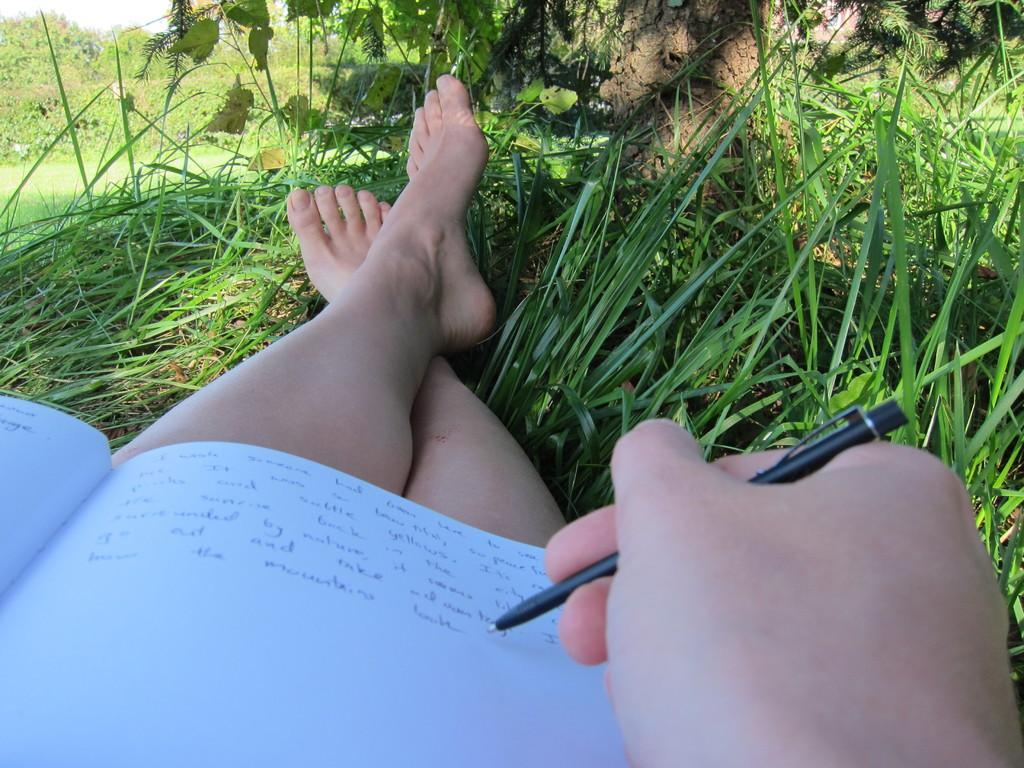Who is the main subject in the image? There is a woman in the image. What is the woman doing in the image? The woman is writing on a book. Where is the book placed in the image? The book is placed on her lap. What type of natural environment is visible in the image? There is grass, plants, and trees visible in the image. What type of liquid is the woman using to write on the book? The woman is not using any liquid to write on the book; she is likely using a pen or pencil. 